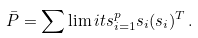<formula> <loc_0><loc_0><loc_500><loc_500>\bar { P } = \sum \lim i t s _ { i = 1 } ^ { p } s _ { i } ( s _ { i } ) ^ { T } \, .</formula> 